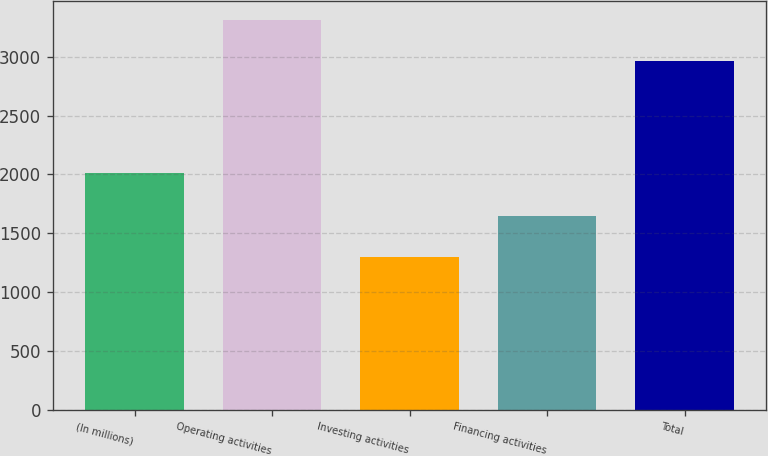<chart> <loc_0><loc_0><loc_500><loc_500><bar_chart><fcel>(In millions)<fcel>Operating activities<fcel>Investing activities<fcel>Financing activities<fcel>Total<nl><fcel>2011<fcel>3309<fcel>1295<fcel>1643<fcel>2961<nl></chart> 